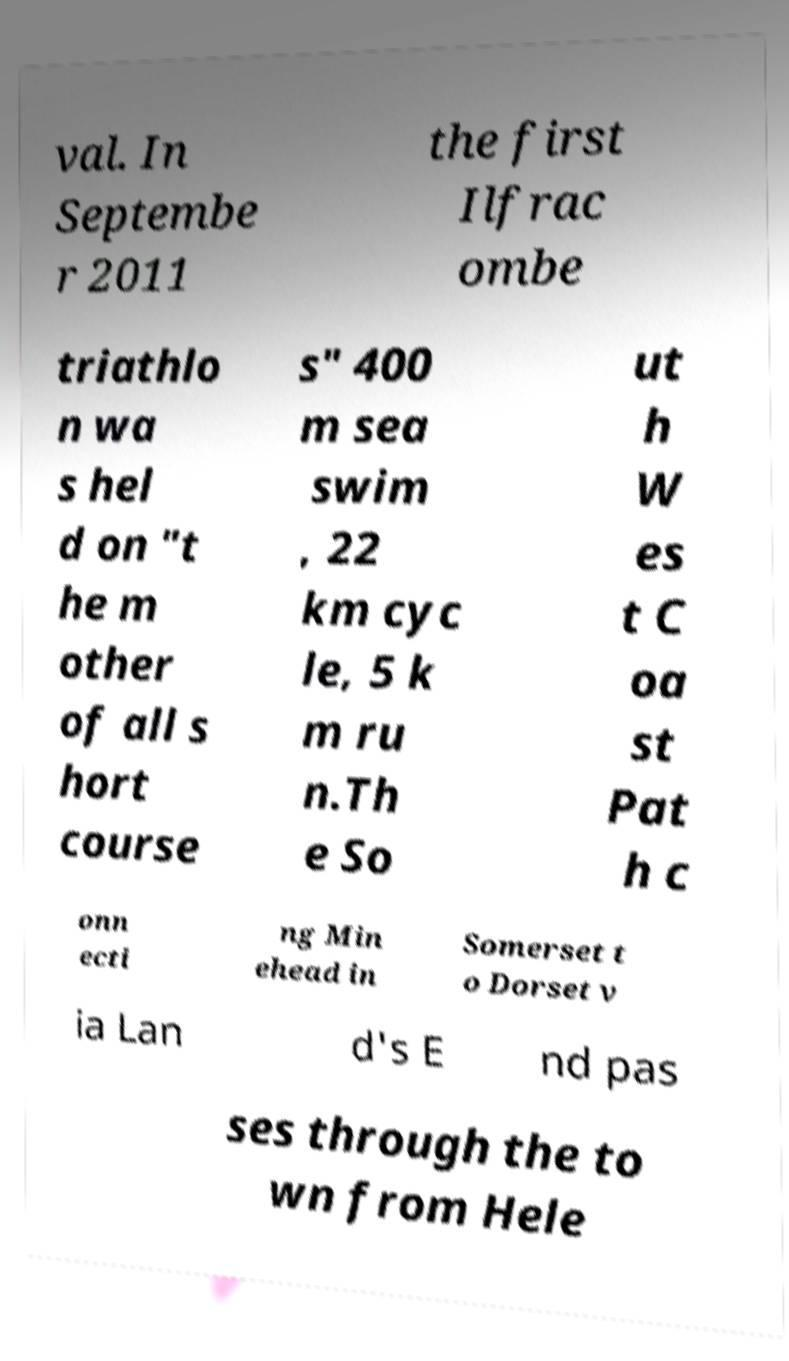For documentation purposes, I need the text within this image transcribed. Could you provide that? val. In Septembe r 2011 the first Ilfrac ombe triathlo n wa s hel d on "t he m other of all s hort course s" 400 m sea swim , 22 km cyc le, 5 k m ru n.Th e So ut h W es t C oa st Pat h c onn ecti ng Min ehead in Somerset t o Dorset v ia Lan d's E nd pas ses through the to wn from Hele 